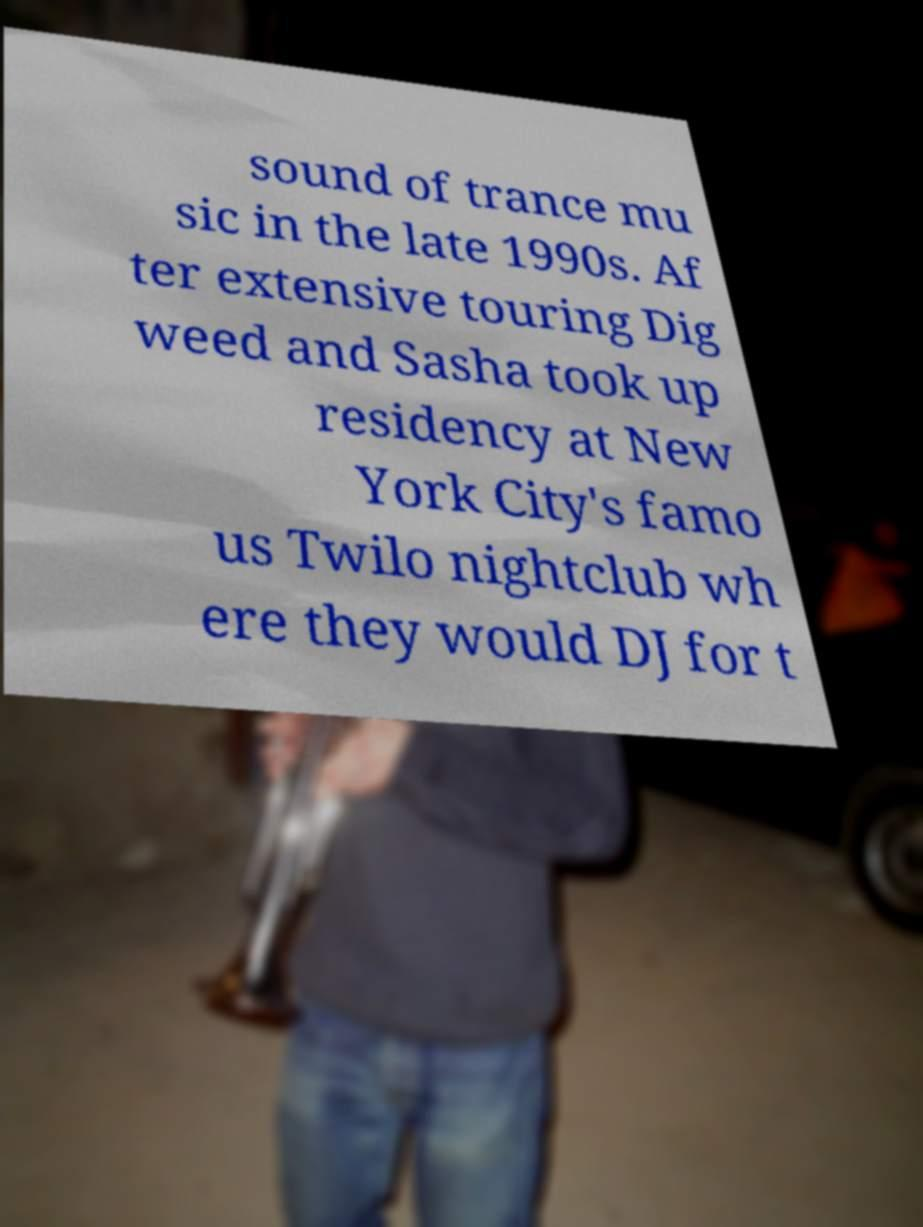Could you assist in decoding the text presented in this image and type it out clearly? sound of trance mu sic in the late 1990s. Af ter extensive touring Dig weed and Sasha took up residency at New York City's famo us Twilo nightclub wh ere they would DJ for t 